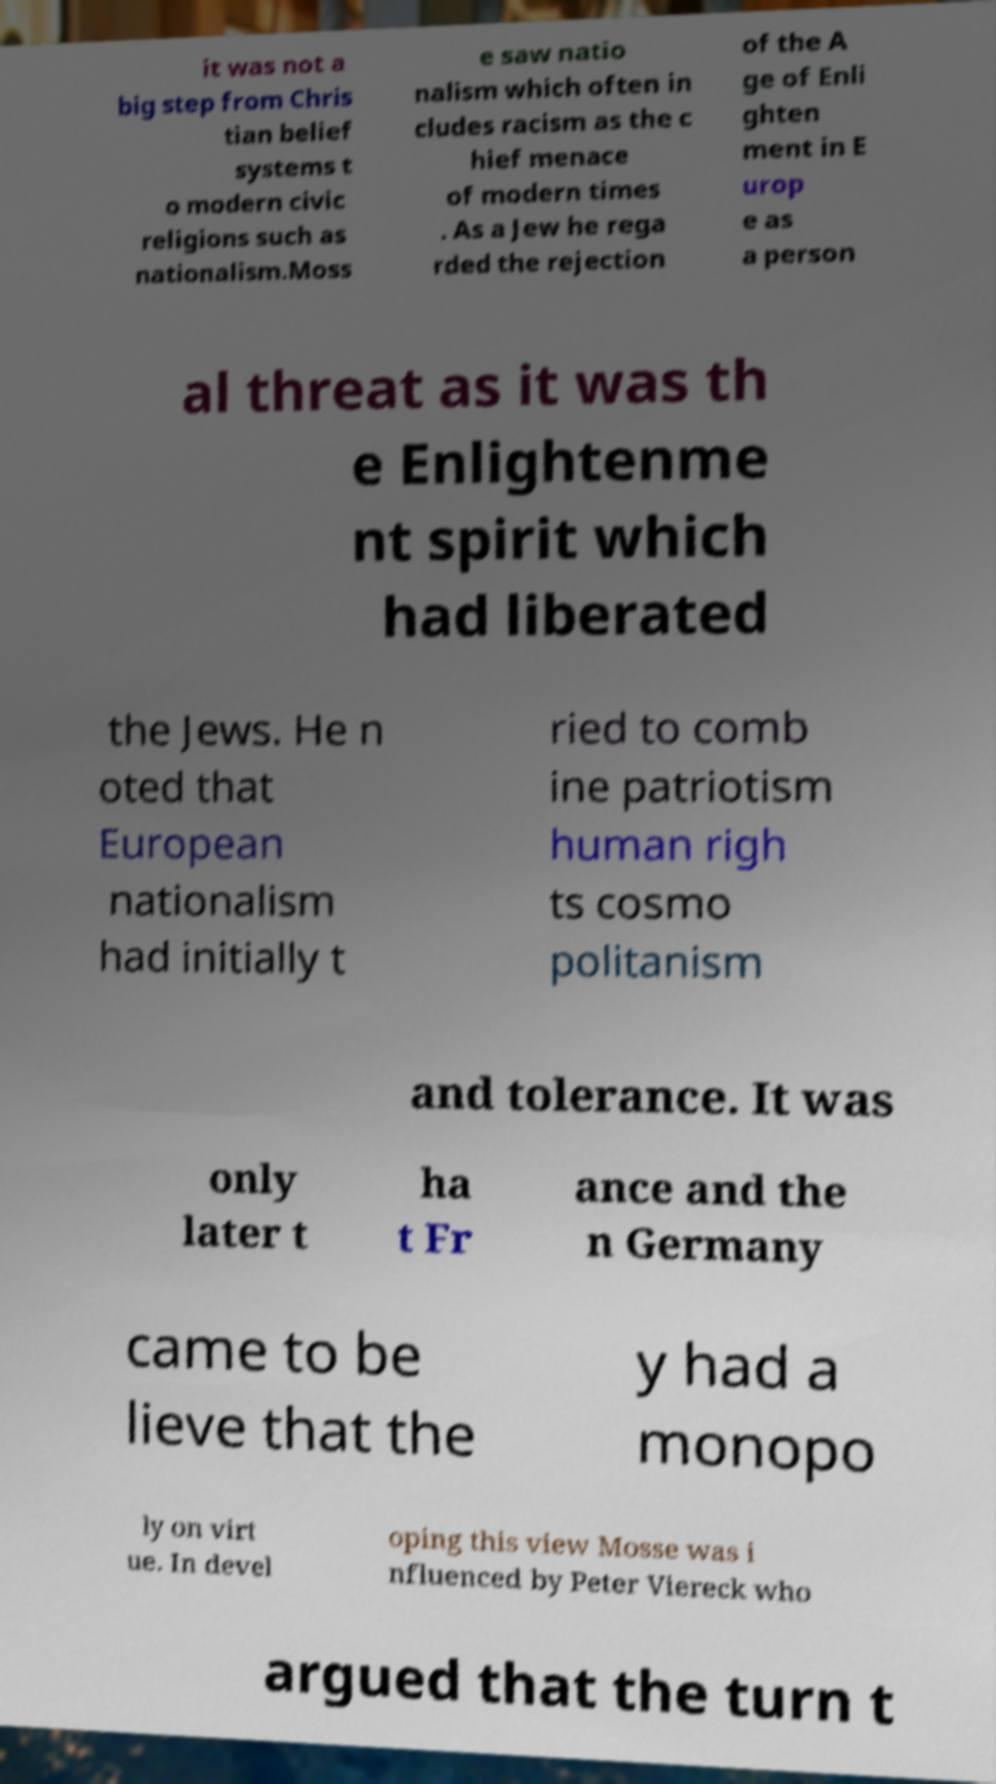There's text embedded in this image that I need extracted. Can you transcribe it verbatim? it was not a big step from Chris tian belief systems t o modern civic religions such as nationalism.Moss e saw natio nalism which often in cludes racism as the c hief menace of modern times . As a Jew he rega rded the rejection of the A ge of Enli ghten ment in E urop e as a person al threat as it was th e Enlightenme nt spirit which had liberated the Jews. He n oted that European nationalism had initially t ried to comb ine patriotism human righ ts cosmo politanism and tolerance. It was only later t ha t Fr ance and the n Germany came to be lieve that the y had a monopo ly on virt ue. In devel oping this view Mosse was i nfluenced by Peter Viereck who argued that the turn t 